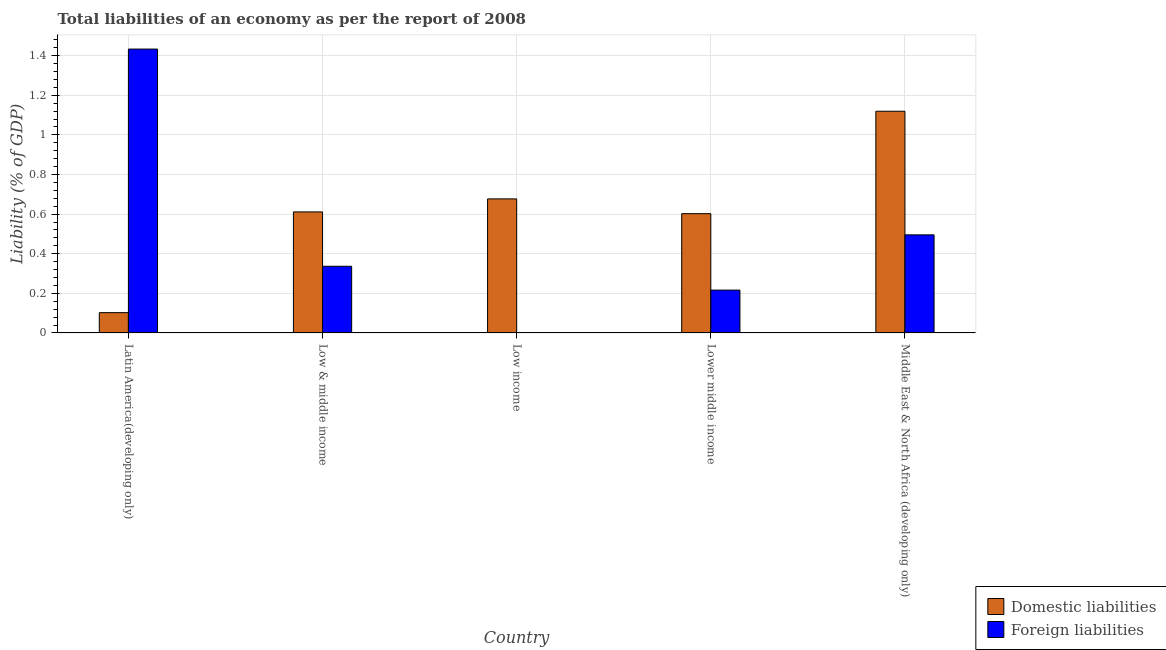How many different coloured bars are there?
Your answer should be very brief. 2. Are the number of bars per tick equal to the number of legend labels?
Offer a terse response. No. Are the number of bars on each tick of the X-axis equal?
Ensure brevity in your answer.  No. What is the label of the 4th group of bars from the left?
Provide a succinct answer. Lower middle income. What is the incurrence of domestic liabilities in Latin America(developing only)?
Your answer should be very brief. 0.1. Across all countries, what is the maximum incurrence of domestic liabilities?
Your answer should be very brief. 1.12. Across all countries, what is the minimum incurrence of foreign liabilities?
Provide a succinct answer. 0. In which country was the incurrence of domestic liabilities maximum?
Offer a very short reply. Middle East & North Africa (developing only). What is the total incurrence of foreign liabilities in the graph?
Give a very brief answer. 2.48. What is the difference between the incurrence of domestic liabilities in Latin America(developing only) and that in Low income?
Give a very brief answer. -0.57. What is the difference between the incurrence of domestic liabilities in Latin America(developing only) and the incurrence of foreign liabilities in Low & middle income?
Give a very brief answer. -0.23. What is the average incurrence of domestic liabilities per country?
Ensure brevity in your answer.  0.62. What is the difference between the incurrence of domestic liabilities and incurrence of foreign liabilities in Low & middle income?
Offer a very short reply. 0.27. What is the ratio of the incurrence of domestic liabilities in Low & middle income to that in Middle East & North Africa (developing only)?
Your response must be concise. 0.55. What is the difference between the highest and the second highest incurrence of foreign liabilities?
Make the answer very short. 0.94. What is the difference between the highest and the lowest incurrence of domestic liabilities?
Ensure brevity in your answer.  1.02. In how many countries, is the incurrence of domestic liabilities greater than the average incurrence of domestic liabilities taken over all countries?
Offer a very short reply. 2. How many bars are there?
Keep it short and to the point. 9. Are all the bars in the graph horizontal?
Ensure brevity in your answer.  No. What is the difference between two consecutive major ticks on the Y-axis?
Offer a terse response. 0.2. Does the graph contain any zero values?
Keep it short and to the point. Yes. How are the legend labels stacked?
Your answer should be very brief. Vertical. What is the title of the graph?
Offer a very short reply. Total liabilities of an economy as per the report of 2008. What is the label or title of the Y-axis?
Keep it short and to the point. Liability (% of GDP). What is the Liability (% of GDP) of Domestic liabilities in Latin America(developing only)?
Provide a short and direct response. 0.1. What is the Liability (% of GDP) in Foreign liabilities in Latin America(developing only)?
Your response must be concise. 1.43. What is the Liability (% of GDP) of Domestic liabilities in Low & middle income?
Give a very brief answer. 0.61. What is the Liability (% of GDP) of Foreign liabilities in Low & middle income?
Keep it short and to the point. 0.34. What is the Liability (% of GDP) of Domestic liabilities in Low income?
Your answer should be compact. 0.68. What is the Liability (% of GDP) of Domestic liabilities in Lower middle income?
Your answer should be very brief. 0.6. What is the Liability (% of GDP) of Foreign liabilities in Lower middle income?
Provide a short and direct response. 0.22. What is the Liability (% of GDP) of Domestic liabilities in Middle East & North Africa (developing only)?
Offer a terse response. 1.12. What is the Liability (% of GDP) in Foreign liabilities in Middle East & North Africa (developing only)?
Your answer should be very brief. 0.5. Across all countries, what is the maximum Liability (% of GDP) of Domestic liabilities?
Keep it short and to the point. 1.12. Across all countries, what is the maximum Liability (% of GDP) of Foreign liabilities?
Provide a succinct answer. 1.43. Across all countries, what is the minimum Liability (% of GDP) in Domestic liabilities?
Your response must be concise. 0.1. Across all countries, what is the minimum Liability (% of GDP) of Foreign liabilities?
Your answer should be very brief. 0. What is the total Liability (% of GDP) of Domestic liabilities in the graph?
Your response must be concise. 3.11. What is the total Liability (% of GDP) of Foreign liabilities in the graph?
Provide a succinct answer. 2.48. What is the difference between the Liability (% of GDP) in Domestic liabilities in Latin America(developing only) and that in Low & middle income?
Offer a terse response. -0.51. What is the difference between the Liability (% of GDP) in Foreign liabilities in Latin America(developing only) and that in Low & middle income?
Make the answer very short. 1.1. What is the difference between the Liability (% of GDP) of Domestic liabilities in Latin America(developing only) and that in Low income?
Give a very brief answer. -0.57. What is the difference between the Liability (% of GDP) in Domestic liabilities in Latin America(developing only) and that in Lower middle income?
Keep it short and to the point. -0.5. What is the difference between the Liability (% of GDP) of Foreign liabilities in Latin America(developing only) and that in Lower middle income?
Give a very brief answer. 1.22. What is the difference between the Liability (% of GDP) of Domestic liabilities in Latin America(developing only) and that in Middle East & North Africa (developing only)?
Keep it short and to the point. -1.02. What is the difference between the Liability (% of GDP) of Foreign liabilities in Latin America(developing only) and that in Middle East & North Africa (developing only)?
Give a very brief answer. 0.94. What is the difference between the Liability (% of GDP) of Domestic liabilities in Low & middle income and that in Low income?
Provide a succinct answer. -0.07. What is the difference between the Liability (% of GDP) in Domestic liabilities in Low & middle income and that in Lower middle income?
Ensure brevity in your answer.  0.01. What is the difference between the Liability (% of GDP) of Foreign liabilities in Low & middle income and that in Lower middle income?
Provide a succinct answer. 0.12. What is the difference between the Liability (% of GDP) of Domestic liabilities in Low & middle income and that in Middle East & North Africa (developing only)?
Give a very brief answer. -0.51. What is the difference between the Liability (% of GDP) in Foreign liabilities in Low & middle income and that in Middle East & North Africa (developing only)?
Keep it short and to the point. -0.16. What is the difference between the Liability (% of GDP) in Domestic liabilities in Low income and that in Lower middle income?
Offer a terse response. 0.07. What is the difference between the Liability (% of GDP) in Domestic liabilities in Low income and that in Middle East & North Africa (developing only)?
Keep it short and to the point. -0.44. What is the difference between the Liability (% of GDP) of Domestic liabilities in Lower middle income and that in Middle East & North Africa (developing only)?
Offer a terse response. -0.52. What is the difference between the Liability (% of GDP) of Foreign liabilities in Lower middle income and that in Middle East & North Africa (developing only)?
Make the answer very short. -0.28. What is the difference between the Liability (% of GDP) of Domestic liabilities in Latin America(developing only) and the Liability (% of GDP) of Foreign liabilities in Low & middle income?
Provide a succinct answer. -0.23. What is the difference between the Liability (% of GDP) in Domestic liabilities in Latin America(developing only) and the Liability (% of GDP) in Foreign liabilities in Lower middle income?
Your answer should be very brief. -0.11. What is the difference between the Liability (% of GDP) of Domestic liabilities in Latin America(developing only) and the Liability (% of GDP) of Foreign liabilities in Middle East & North Africa (developing only)?
Keep it short and to the point. -0.39. What is the difference between the Liability (% of GDP) in Domestic liabilities in Low & middle income and the Liability (% of GDP) in Foreign liabilities in Lower middle income?
Your answer should be very brief. 0.39. What is the difference between the Liability (% of GDP) in Domestic liabilities in Low & middle income and the Liability (% of GDP) in Foreign liabilities in Middle East & North Africa (developing only)?
Provide a succinct answer. 0.12. What is the difference between the Liability (% of GDP) in Domestic liabilities in Low income and the Liability (% of GDP) in Foreign liabilities in Lower middle income?
Your answer should be compact. 0.46. What is the difference between the Liability (% of GDP) in Domestic liabilities in Low income and the Liability (% of GDP) in Foreign liabilities in Middle East & North Africa (developing only)?
Offer a very short reply. 0.18. What is the difference between the Liability (% of GDP) of Domestic liabilities in Lower middle income and the Liability (% of GDP) of Foreign liabilities in Middle East & North Africa (developing only)?
Your answer should be very brief. 0.11. What is the average Liability (% of GDP) of Domestic liabilities per country?
Offer a very short reply. 0.62. What is the average Liability (% of GDP) of Foreign liabilities per country?
Make the answer very short. 0.5. What is the difference between the Liability (% of GDP) of Domestic liabilities and Liability (% of GDP) of Foreign liabilities in Latin America(developing only)?
Provide a succinct answer. -1.33. What is the difference between the Liability (% of GDP) of Domestic liabilities and Liability (% of GDP) of Foreign liabilities in Low & middle income?
Provide a succinct answer. 0.27. What is the difference between the Liability (% of GDP) in Domestic liabilities and Liability (% of GDP) in Foreign liabilities in Lower middle income?
Keep it short and to the point. 0.39. What is the difference between the Liability (% of GDP) of Domestic liabilities and Liability (% of GDP) of Foreign liabilities in Middle East & North Africa (developing only)?
Your response must be concise. 0.62. What is the ratio of the Liability (% of GDP) of Domestic liabilities in Latin America(developing only) to that in Low & middle income?
Keep it short and to the point. 0.17. What is the ratio of the Liability (% of GDP) in Foreign liabilities in Latin America(developing only) to that in Low & middle income?
Your answer should be very brief. 4.26. What is the ratio of the Liability (% of GDP) of Domestic liabilities in Latin America(developing only) to that in Low income?
Offer a terse response. 0.15. What is the ratio of the Liability (% of GDP) of Domestic liabilities in Latin America(developing only) to that in Lower middle income?
Provide a succinct answer. 0.17. What is the ratio of the Liability (% of GDP) of Foreign liabilities in Latin America(developing only) to that in Lower middle income?
Ensure brevity in your answer.  6.63. What is the ratio of the Liability (% of GDP) in Domestic liabilities in Latin America(developing only) to that in Middle East & North Africa (developing only)?
Provide a succinct answer. 0.09. What is the ratio of the Liability (% of GDP) in Foreign liabilities in Latin America(developing only) to that in Middle East & North Africa (developing only)?
Ensure brevity in your answer.  2.89. What is the ratio of the Liability (% of GDP) of Domestic liabilities in Low & middle income to that in Low income?
Give a very brief answer. 0.9. What is the ratio of the Liability (% of GDP) of Domestic liabilities in Low & middle income to that in Lower middle income?
Your response must be concise. 1.01. What is the ratio of the Liability (% of GDP) of Foreign liabilities in Low & middle income to that in Lower middle income?
Provide a succinct answer. 1.56. What is the ratio of the Liability (% of GDP) of Domestic liabilities in Low & middle income to that in Middle East & North Africa (developing only)?
Your answer should be very brief. 0.55. What is the ratio of the Liability (% of GDP) of Foreign liabilities in Low & middle income to that in Middle East & North Africa (developing only)?
Make the answer very short. 0.68. What is the ratio of the Liability (% of GDP) in Domestic liabilities in Low income to that in Lower middle income?
Your answer should be very brief. 1.12. What is the ratio of the Liability (% of GDP) in Domestic liabilities in Low income to that in Middle East & North Africa (developing only)?
Your response must be concise. 0.6. What is the ratio of the Liability (% of GDP) of Domestic liabilities in Lower middle income to that in Middle East & North Africa (developing only)?
Your answer should be very brief. 0.54. What is the ratio of the Liability (% of GDP) of Foreign liabilities in Lower middle income to that in Middle East & North Africa (developing only)?
Your response must be concise. 0.44. What is the difference between the highest and the second highest Liability (% of GDP) in Domestic liabilities?
Keep it short and to the point. 0.44. What is the difference between the highest and the second highest Liability (% of GDP) of Foreign liabilities?
Your answer should be very brief. 0.94. What is the difference between the highest and the lowest Liability (% of GDP) of Domestic liabilities?
Give a very brief answer. 1.02. What is the difference between the highest and the lowest Liability (% of GDP) of Foreign liabilities?
Provide a short and direct response. 1.43. 